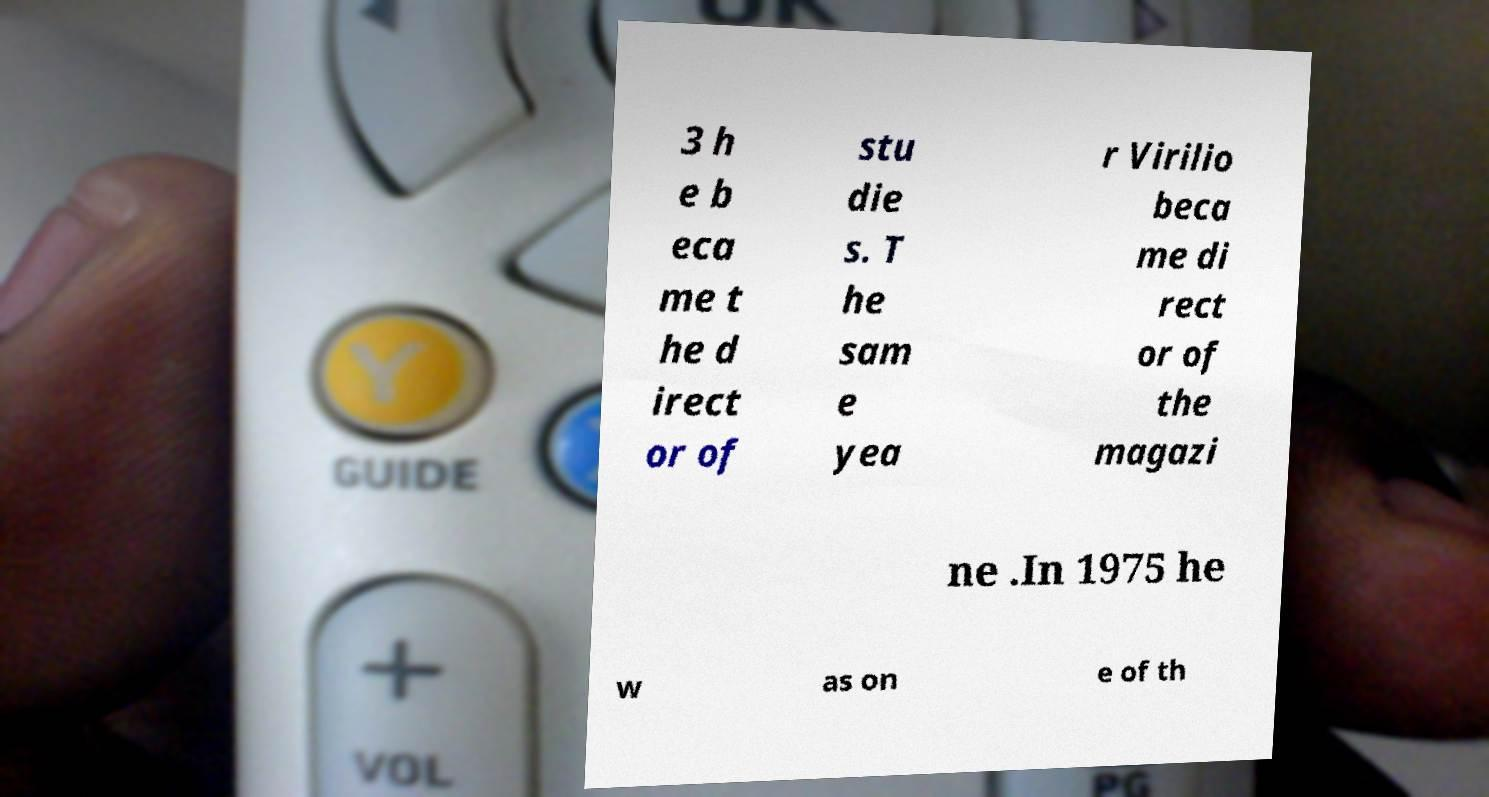Could you extract and type out the text from this image? 3 h e b eca me t he d irect or of stu die s. T he sam e yea r Virilio beca me di rect or of the magazi ne .In 1975 he w as on e of th 